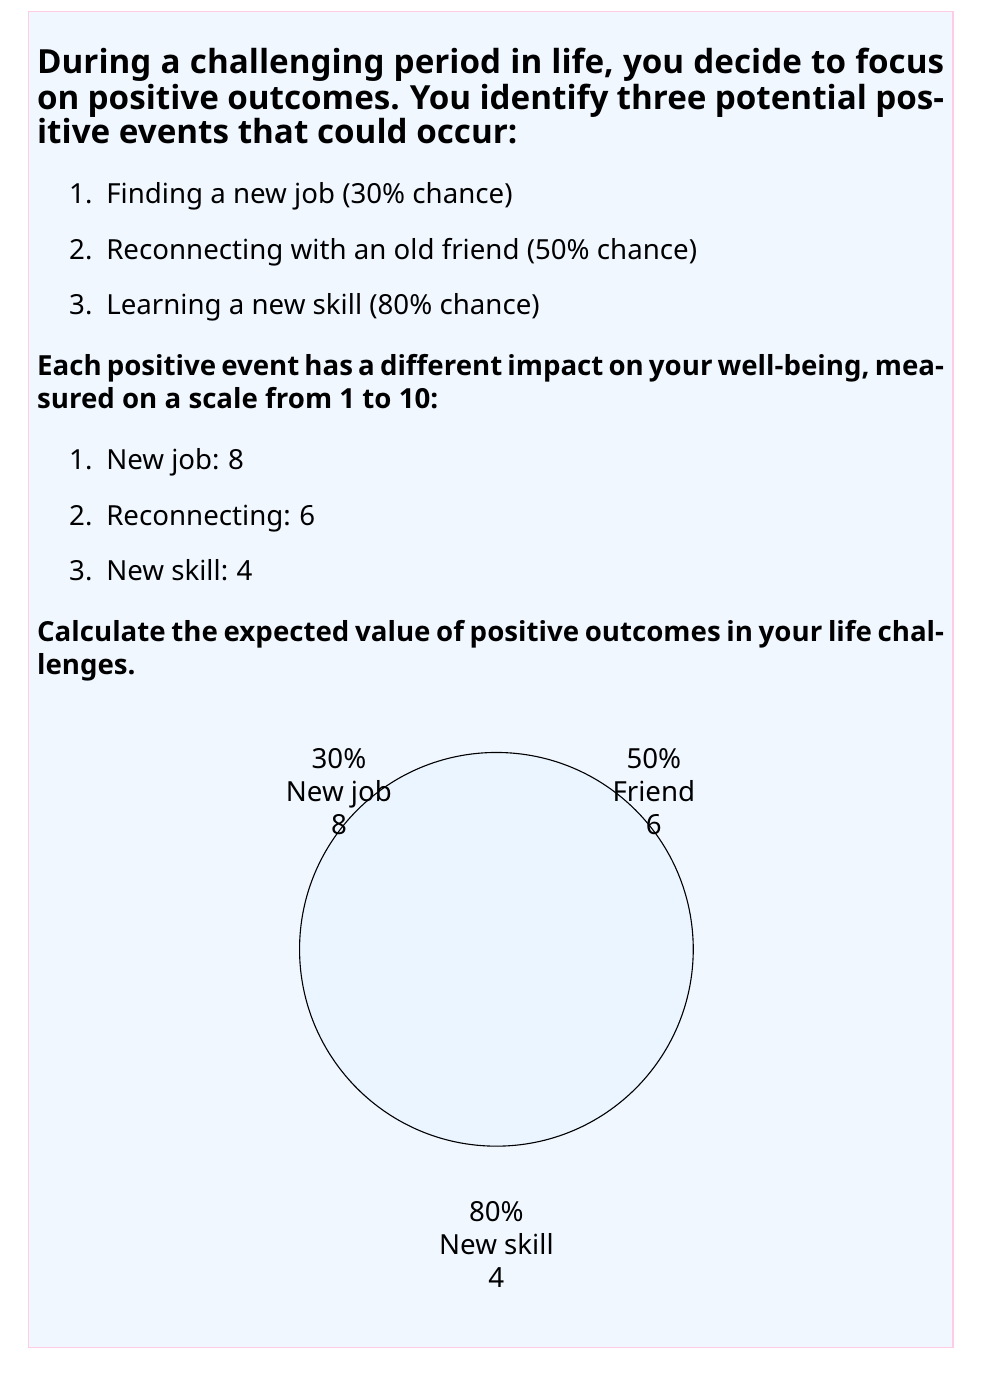Solve this math problem. To calculate the expected value of positive outcomes, we need to multiply the probability of each event occurring by its impact value and then sum these products. Let's break it down step-by-step:

1. For the new job:
   Probability = 30% = 0.3
   Impact value = 8
   Expected value = $0.3 \times 8 = 2.4$

2. For reconnecting with an old friend:
   Probability = 50% = 0.5
   Impact value = 6
   Expected value = $0.5 \times 6 = 3$

3. For learning a new skill:
   Probability = 80% = 0.8
   Impact value = 4
   Expected value = $0.8 \times 4 = 3.2$

Now, we sum up all these expected values:

$$ \text{Total Expected Value} = 2.4 + 3 + 3.2 = 8.6 $$

Therefore, the expected value of positive outcomes in your life challenges is 8.6 on the well-being scale.

This value represents the average impact on your well-being you can expect from these positive events, taking into account both their likelihood of occurrence and their individual impacts.
Answer: $8.6$ 